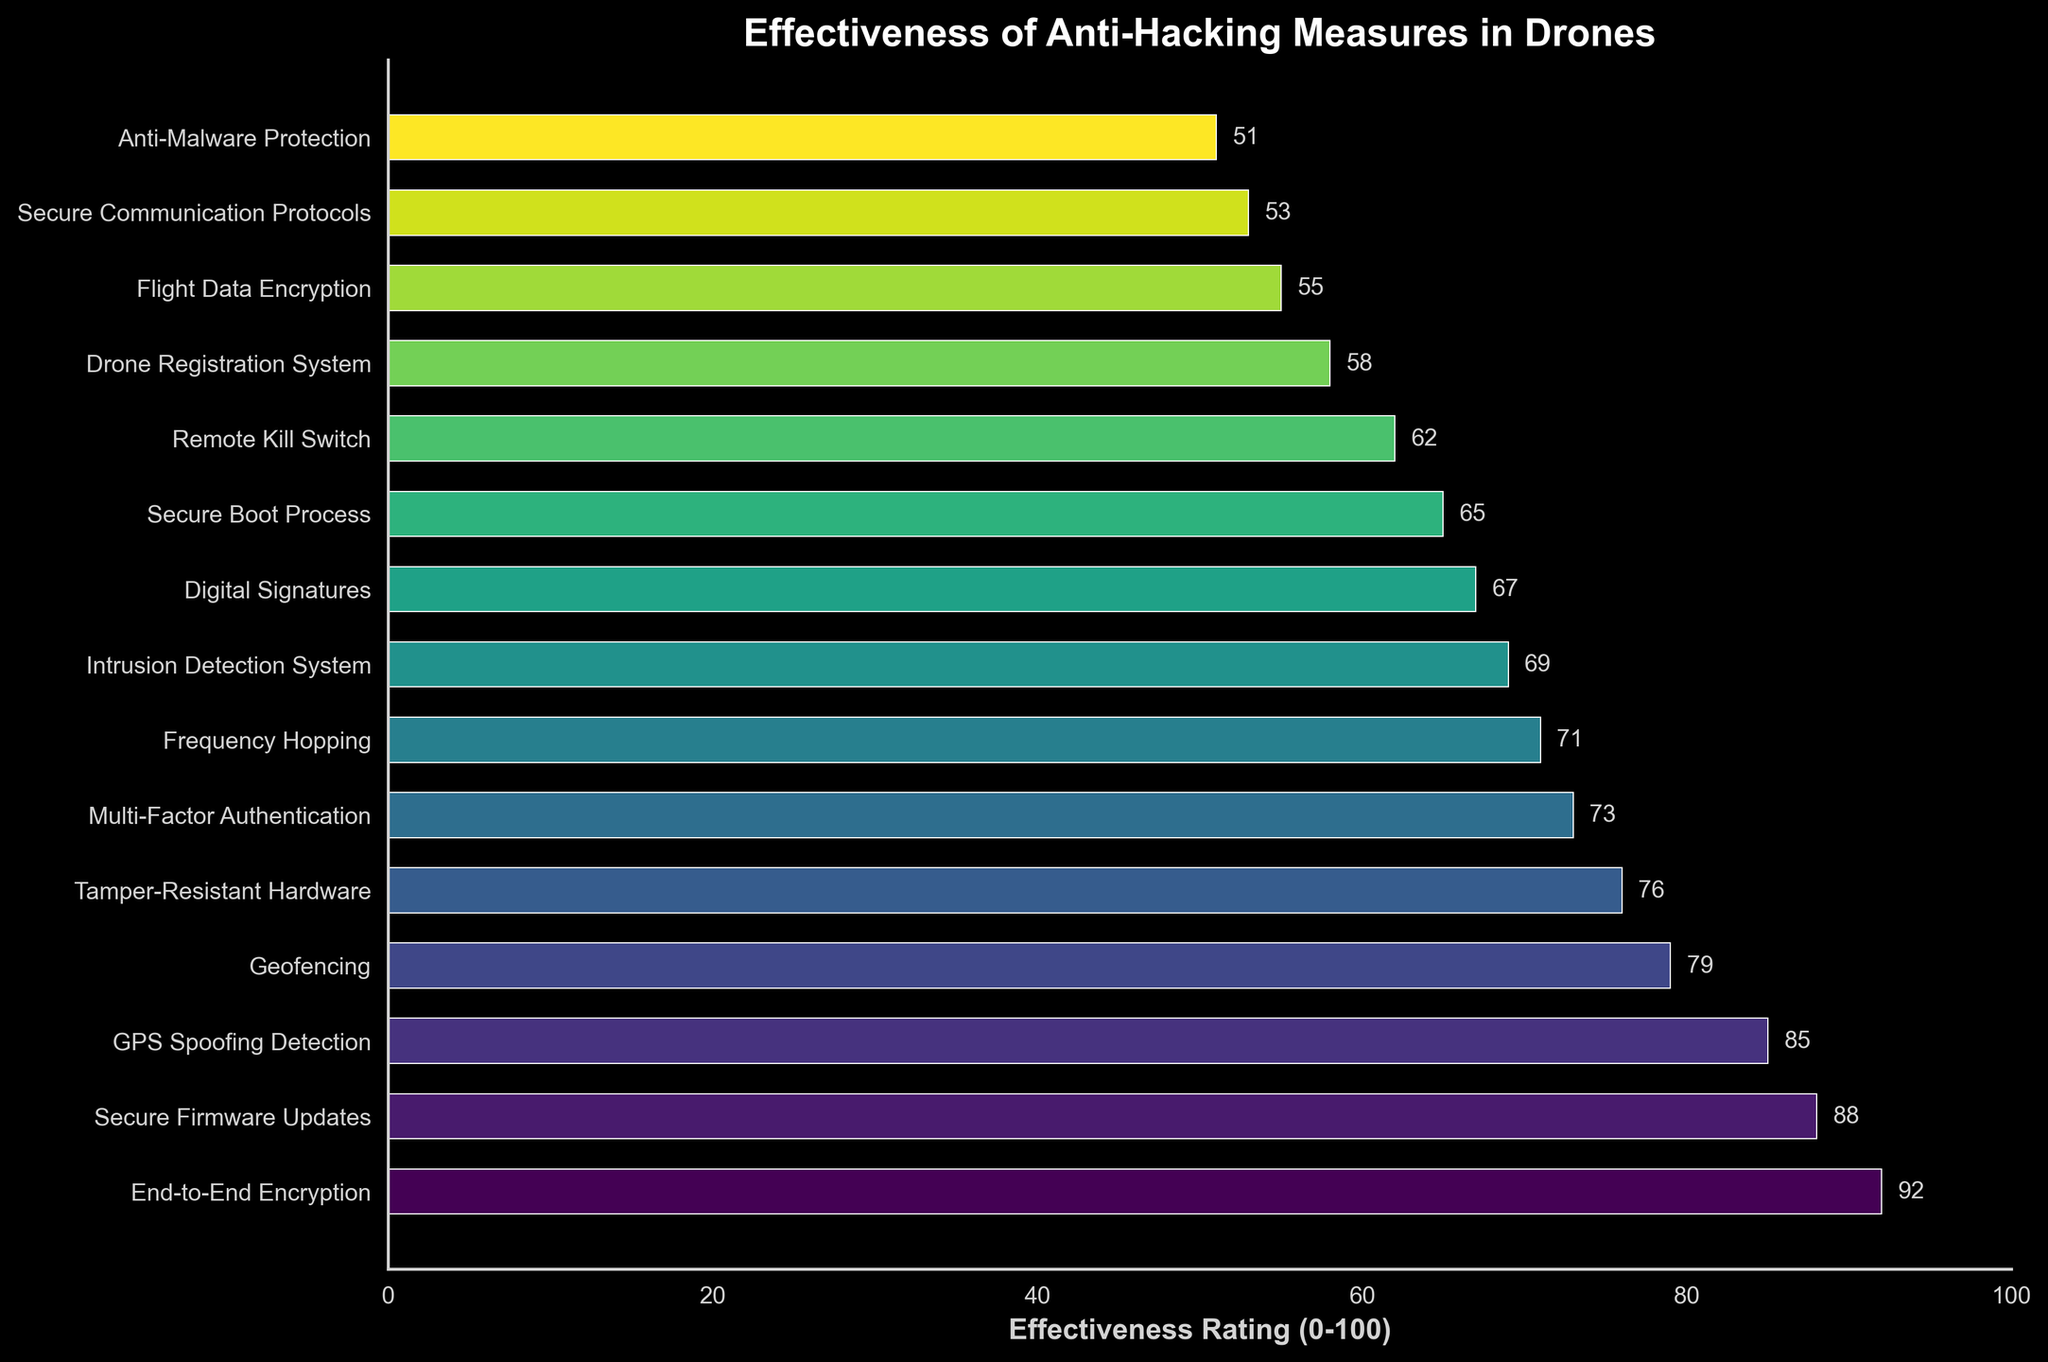Which measure has the highest effectiveness rating? The measure with the highest effectiveness rating is identified by looking for the bar that extends farthest to the right on the horizontal axis. End-to-End Encryption is the longest bar, indicating the highest effectiveness rating.
Answer: End-to-End Encryption Which measures have an effectiveness rating below 60? Measures with ratings below 60 can be found by identifying the bars that do not extend past the 60 mark on the horizontal axis. These are Remote Kill Switch, Drone Registration System, Flight Data Encryption, Secure Communication Protocols, and Anti-Malware Protection.
Answer: Remote Kill Switch, Drone Registration System, Flight Data Encryption, Secure Communication Protocols, Anti-Malware Protection What is the difference in effectiveness ratings between GPS Spoofing Detection and Multi-Factor Authentication? To find the difference, subtract the effectiveness rating of Multi-Factor Authentication from that of GPS Spoofing Detection (85 - 73). The result is 12.
Answer: 12 Which measure is least effective, and what is its rating? The least effective measure is found by locating the shortest bar on the chart. This bar belongs to Anti-Malware Protection, which has the lowest effectiveness rating of 51.
Answer: Anti-Malware Protection, 51 How many measures have an effectiveness rating of 80 or above? Count the number of bars that extend to or beyond the 80 mark on the horizontal axis. These measures are End-to-End Encryption, Secure Firmware Updates, and GPS Spoofing Detection, totaling 3 measures.
Answer: 3 What is the average effectiveness rating of the measures with top 5 highest ratings? Identify the top 5 measures with the highest ratings from the chart: End-to-End Encryption, Secure Firmware Updates, GPS Spoofing Detection, Geofencing, and Tamper-Resistant Hardware. Their ratings are 92, 88, 85, 79, and 76 respectively. Calculate the average by summing these ratings (92 + 88 + 85 + 79 + 76 = 420) and dividing by 5 (420 / 5). The average is 84.
Answer: 84 Which measures fall within the 60-70 effectiveness rating range? Measures within the 60-70 range can be identified by finding the bars that fall between the 60 and 70 marks on the horizontal axis. These measures are Intrusion Detection System, Secure Boot Process, and Remote Kill Switch.
Answer: Intrusion Detection System, Secure Boot Process, Remote Kill Switch How much higher is the effectiveness rating of Digital Signatures compared to Secure Communication Protocols? Find the difference by subtracting the effectiveness rating of Secure Communication Protocols from that of Digital Signatures (67 - 53). The result is 14.
Answer: 14 What are the ratings for Geofencing and Flight Data Encryption, and what is their sum? Geofencing has an effectiveness rating of 79, and Flight Data Encryption has a rating of 55. Their sum is obtained by simply adding these two ratings (79 + 55). The sum is 134.
Answer: 134 What is the median effectiveness rating of all the measures? To find the median, first list all ratings in ascending order: 51, 53, 55, 58, 62, 65, 67, 69, 71, 73, 76, 79, 85, 88, 92. With 15 values listed, the median is the 8th value in this ordered list, which is 69.
Answer: 69 